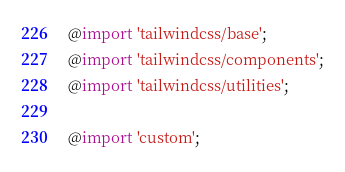<code> <loc_0><loc_0><loc_500><loc_500><_CSS_>@import 'tailwindcss/base';
@import 'tailwindcss/components';
@import 'tailwindcss/utilities';

@import 'custom';</code> 